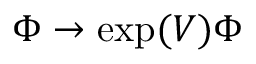<formula> <loc_0><loc_0><loc_500><loc_500>\Phi \rightarrow \exp ( V ) \Phi</formula> 